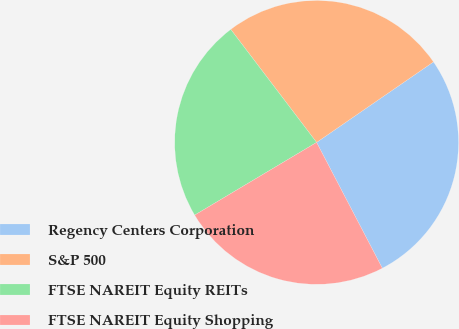Convert chart. <chart><loc_0><loc_0><loc_500><loc_500><pie_chart><fcel>Regency Centers Corporation<fcel>S&P 500<fcel>FTSE NAREIT Equity REITs<fcel>FTSE NAREIT Equity Shopping<nl><fcel>26.94%<fcel>25.74%<fcel>23.22%<fcel>24.11%<nl></chart> 